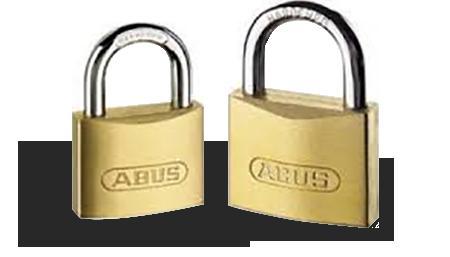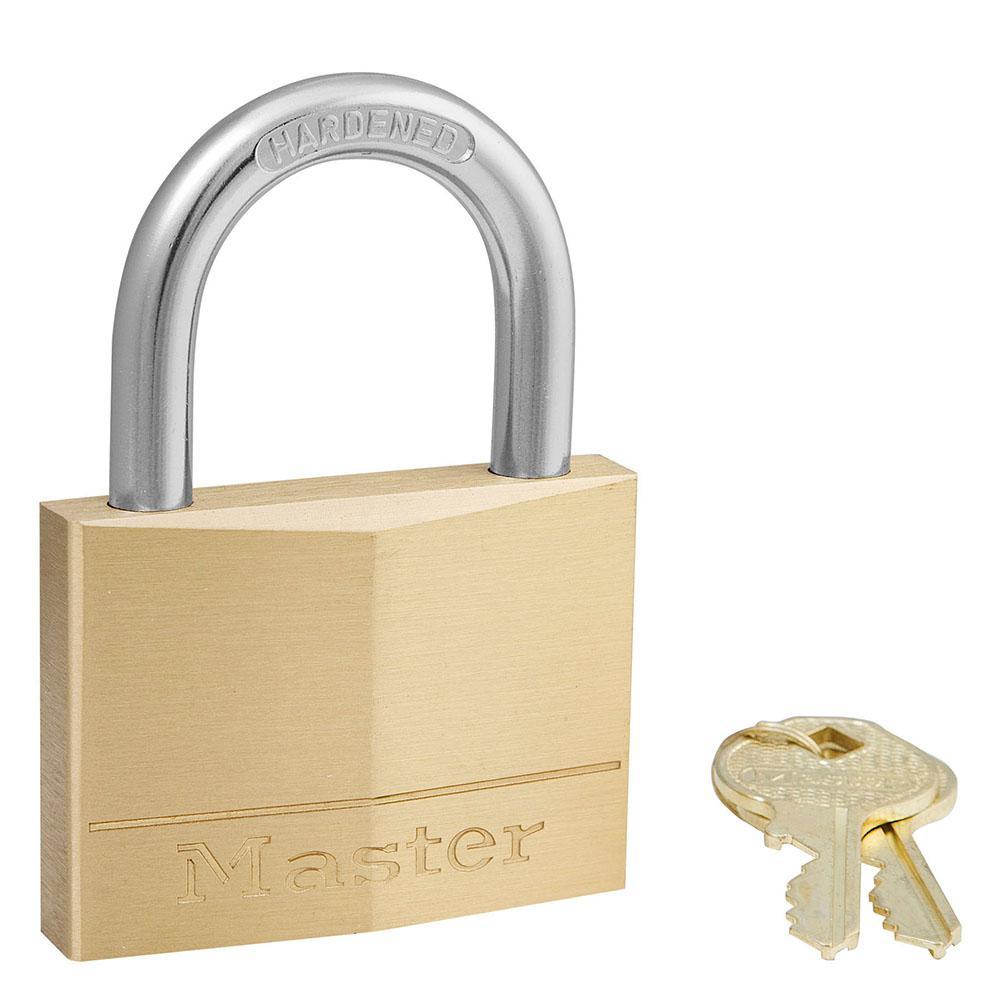The first image is the image on the left, the second image is the image on the right. Evaluate the accuracy of this statement regarding the images: "An image shows a ring of keys next to, but not attached to, an upright lock.". Is it true? Answer yes or no. Yes. The first image is the image on the left, the second image is the image on the right. Given the left and right images, does the statement "There's at least two keys in the right image." hold true? Answer yes or no. Yes. 